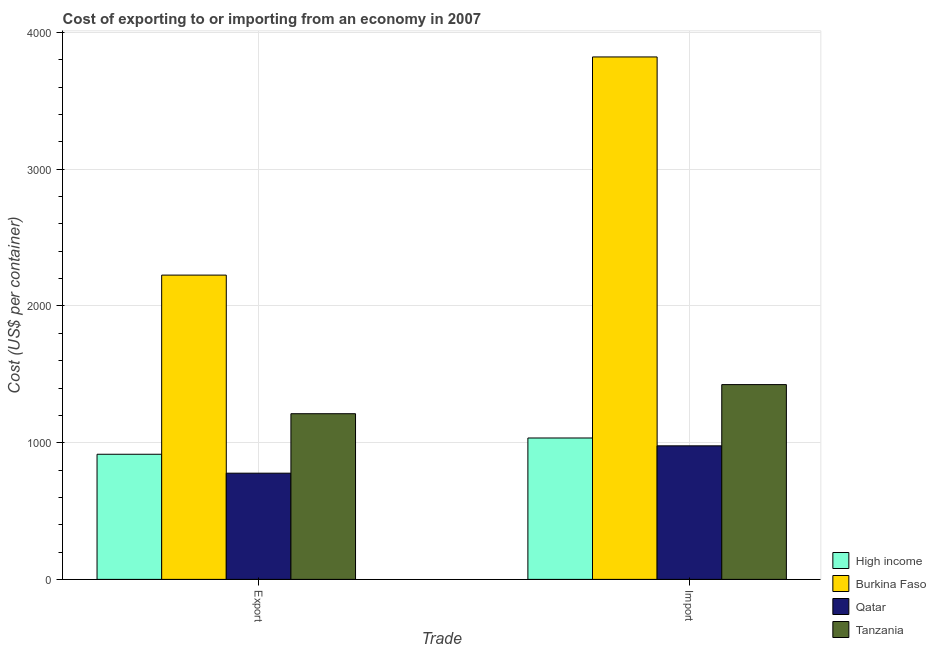Are the number of bars per tick equal to the number of legend labels?
Offer a very short reply. Yes. How many bars are there on the 2nd tick from the left?
Provide a succinct answer. 4. What is the label of the 1st group of bars from the left?
Make the answer very short. Export. What is the export cost in High income?
Your answer should be compact. 915.43. Across all countries, what is the maximum import cost?
Offer a terse response. 3822. Across all countries, what is the minimum export cost?
Provide a short and direct response. 777. In which country was the import cost maximum?
Provide a short and direct response. Burkina Faso. In which country was the import cost minimum?
Your response must be concise. Qatar. What is the total import cost in the graph?
Your answer should be compact. 7258.41. What is the difference between the export cost in Qatar and that in Tanzania?
Offer a very short reply. -435. What is the difference between the import cost in Burkina Faso and the export cost in High income?
Provide a succinct answer. 2906.57. What is the average export cost per country?
Your answer should be very brief. 1282.61. What is the difference between the import cost and export cost in Qatar?
Provide a succinct answer. 200. What is the ratio of the import cost in Burkina Faso to that in High income?
Give a very brief answer. 3.69. In how many countries, is the export cost greater than the average export cost taken over all countries?
Provide a short and direct response. 1. What does the 4th bar from the left in Import represents?
Provide a short and direct response. Tanzania. What does the 2nd bar from the right in Export represents?
Provide a short and direct response. Qatar. How many countries are there in the graph?
Your answer should be compact. 4. Are the values on the major ticks of Y-axis written in scientific E-notation?
Ensure brevity in your answer.  No. Does the graph contain any zero values?
Your answer should be very brief. No. How are the legend labels stacked?
Keep it short and to the point. Vertical. What is the title of the graph?
Provide a succinct answer. Cost of exporting to or importing from an economy in 2007. Does "Channel Islands" appear as one of the legend labels in the graph?
Your answer should be very brief. No. What is the label or title of the X-axis?
Provide a succinct answer. Trade. What is the label or title of the Y-axis?
Provide a short and direct response. Cost (US$ per container). What is the Cost (US$ per container) in High income in Export?
Offer a very short reply. 915.43. What is the Cost (US$ per container) in Burkina Faso in Export?
Make the answer very short. 2226. What is the Cost (US$ per container) of Qatar in Export?
Offer a very short reply. 777. What is the Cost (US$ per container) in Tanzania in Export?
Offer a very short reply. 1212. What is the Cost (US$ per container) of High income in Import?
Your response must be concise. 1034.41. What is the Cost (US$ per container) of Burkina Faso in Import?
Keep it short and to the point. 3822. What is the Cost (US$ per container) in Qatar in Import?
Your answer should be very brief. 977. What is the Cost (US$ per container) of Tanzania in Import?
Your answer should be very brief. 1425. Across all Trade, what is the maximum Cost (US$ per container) in High income?
Your answer should be very brief. 1034.41. Across all Trade, what is the maximum Cost (US$ per container) of Burkina Faso?
Give a very brief answer. 3822. Across all Trade, what is the maximum Cost (US$ per container) of Qatar?
Your answer should be compact. 977. Across all Trade, what is the maximum Cost (US$ per container) of Tanzania?
Your answer should be very brief. 1425. Across all Trade, what is the minimum Cost (US$ per container) of High income?
Your answer should be very brief. 915.43. Across all Trade, what is the minimum Cost (US$ per container) of Burkina Faso?
Give a very brief answer. 2226. Across all Trade, what is the minimum Cost (US$ per container) of Qatar?
Make the answer very short. 777. Across all Trade, what is the minimum Cost (US$ per container) of Tanzania?
Your answer should be compact. 1212. What is the total Cost (US$ per container) of High income in the graph?
Your response must be concise. 1949.84. What is the total Cost (US$ per container) of Burkina Faso in the graph?
Give a very brief answer. 6048. What is the total Cost (US$ per container) in Qatar in the graph?
Ensure brevity in your answer.  1754. What is the total Cost (US$ per container) of Tanzania in the graph?
Make the answer very short. 2637. What is the difference between the Cost (US$ per container) in High income in Export and that in Import?
Offer a very short reply. -118.98. What is the difference between the Cost (US$ per container) of Burkina Faso in Export and that in Import?
Make the answer very short. -1596. What is the difference between the Cost (US$ per container) of Qatar in Export and that in Import?
Your answer should be compact. -200. What is the difference between the Cost (US$ per container) of Tanzania in Export and that in Import?
Give a very brief answer. -213. What is the difference between the Cost (US$ per container) in High income in Export and the Cost (US$ per container) in Burkina Faso in Import?
Ensure brevity in your answer.  -2906.57. What is the difference between the Cost (US$ per container) in High income in Export and the Cost (US$ per container) in Qatar in Import?
Make the answer very short. -61.57. What is the difference between the Cost (US$ per container) of High income in Export and the Cost (US$ per container) of Tanzania in Import?
Ensure brevity in your answer.  -509.57. What is the difference between the Cost (US$ per container) of Burkina Faso in Export and the Cost (US$ per container) of Qatar in Import?
Provide a succinct answer. 1249. What is the difference between the Cost (US$ per container) in Burkina Faso in Export and the Cost (US$ per container) in Tanzania in Import?
Make the answer very short. 801. What is the difference between the Cost (US$ per container) of Qatar in Export and the Cost (US$ per container) of Tanzania in Import?
Make the answer very short. -648. What is the average Cost (US$ per container) in High income per Trade?
Your answer should be very brief. 974.92. What is the average Cost (US$ per container) in Burkina Faso per Trade?
Your answer should be compact. 3024. What is the average Cost (US$ per container) in Qatar per Trade?
Provide a short and direct response. 877. What is the average Cost (US$ per container) of Tanzania per Trade?
Provide a succinct answer. 1318.5. What is the difference between the Cost (US$ per container) of High income and Cost (US$ per container) of Burkina Faso in Export?
Keep it short and to the point. -1310.57. What is the difference between the Cost (US$ per container) in High income and Cost (US$ per container) in Qatar in Export?
Keep it short and to the point. 138.43. What is the difference between the Cost (US$ per container) of High income and Cost (US$ per container) of Tanzania in Export?
Your answer should be very brief. -296.57. What is the difference between the Cost (US$ per container) in Burkina Faso and Cost (US$ per container) in Qatar in Export?
Your answer should be very brief. 1449. What is the difference between the Cost (US$ per container) in Burkina Faso and Cost (US$ per container) in Tanzania in Export?
Offer a terse response. 1014. What is the difference between the Cost (US$ per container) of Qatar and Cost (US$ per container) of Tanzania in Export?
Give a very brief answer. -435. What is the difference between the Cost (US$ per container) in High income and Cost (US$ per container) in Burkina Faso in Import?
Provide a short and direct response. -2787.59. What is the difference between the Cost (US$ per container) of High income and Cost (US$ per container) of Qatar in Import?
Provide a succinct answer. 57.41. What is the difference between the Cost (US$ per container) of High income and Cost (US$ per container) of Tanzania in Import?
Offer a very short reply. -390.59. What is the difference between the Cost (US$ per container) in Burkina Faso and Cost (US$ per container) in Qatar in Import?
Make the answer very short. 2845. What is the difference between the Cost (US$ per container) of Burkina Faso and Cost (US$ per container) of Tanzania in Import?
Provide a succinct answer. 2397. What is the difference between the Cost (US$ per container) in Qatar and Cost (US$ per container) in Tanzania in Import?
Provide a short and direct response. -448. What is the ratio of the Cost (US$ per container) in High income in Export to that in Import?
Give a very brief answer. 0.89. What is the ratio of the Cost (US$ per container) in Burkina Faso in Export to that in Import?
Your answer should be compact. 0.58. What is the ratio of the Cost (US$ per container) of Qatar in Export to that in Import?
Provide a succinct answer. 0.8. What is the ratio of the Cost (US$ per container) of Tanzania in Export to that in Import?
Offer a terse response. 0.85. What is the difference between the highest and the second highest Cost (US$ per container) of High income?
Make the answer very short. 118.98. What is the difference between the highest and the second highest Cost (US$ per container) in Burkina Faso?
Offer a terse response. 1596. What is the difference between the highest and the second highest Cost (US$ per container) of Tanzania?
Make the answer very short. 213. What is the difference between the highest and the lowest Cost (US$ per container) of High income?
Your response must be concise. 118.98. What is the difference between the highest and the lowest Cost (US$ per container) in Burkina Faso?
Your response must be concise. 1596. What is the difference between the highest and the lowest Cost (US$ per container) of Qatar?
Keep it short and to the point. 200. What is the difference between the highest and the lowest Cost (US$ per container) of Tanzania?
Offer a terse response. 213. 